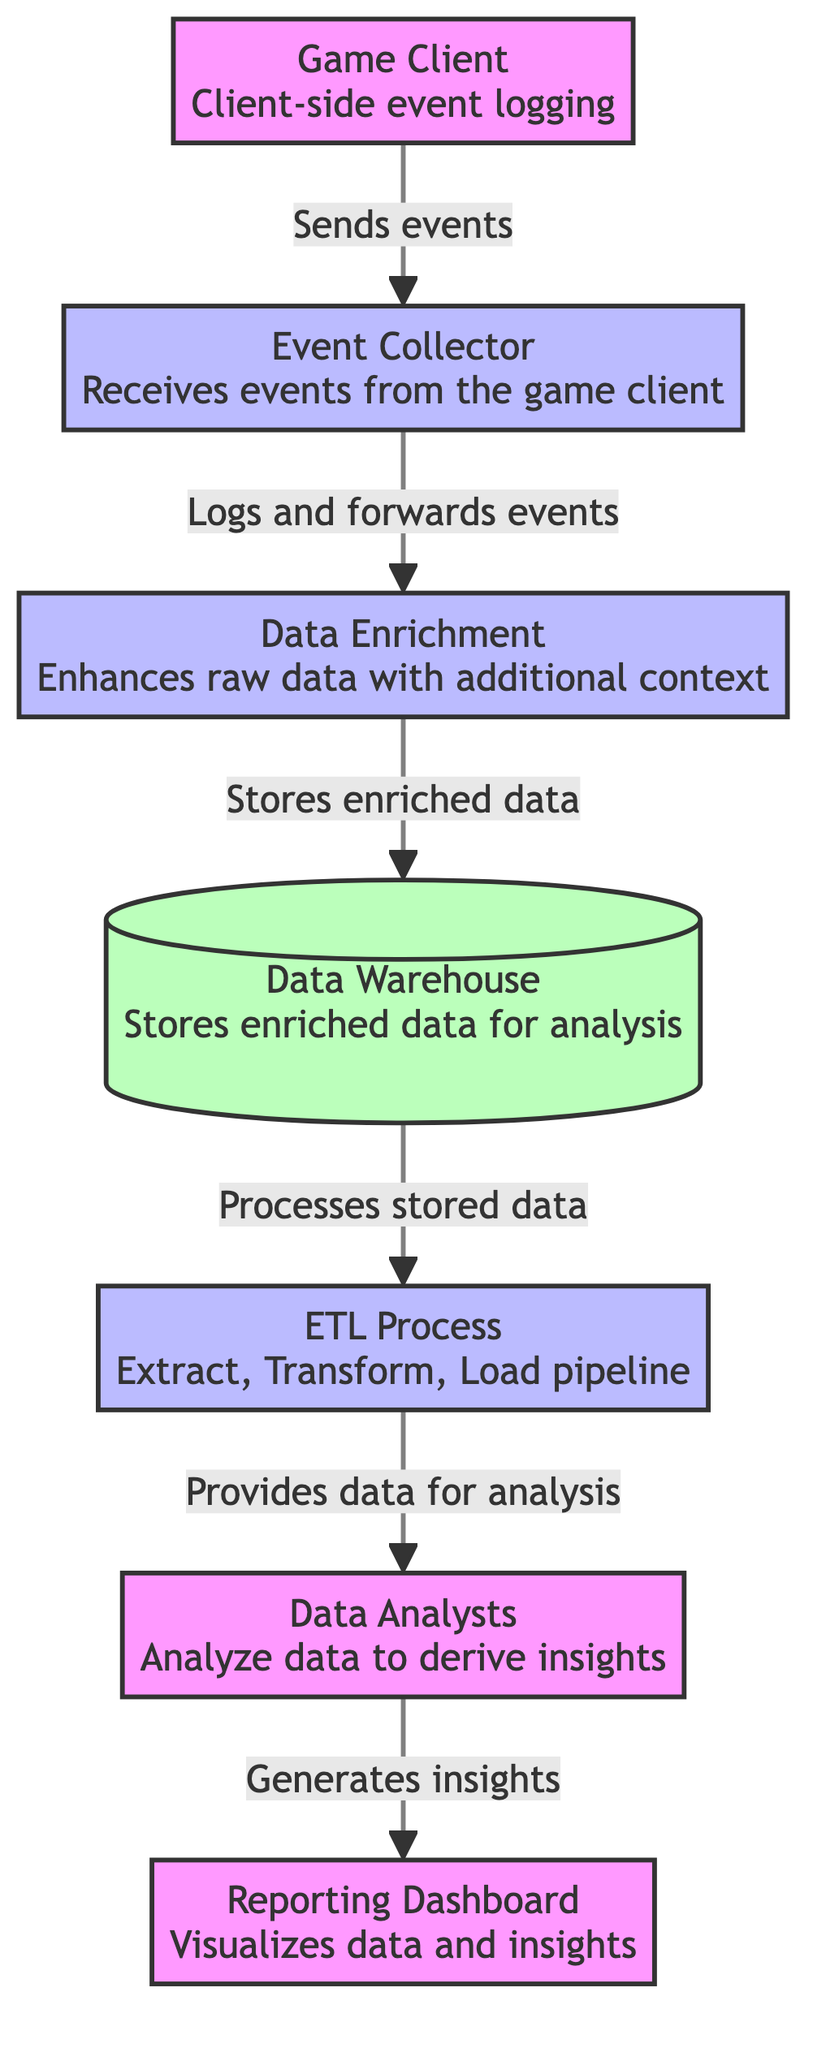What is the first step in the data flow? The diagram starts with the "Game Client" step, which involves client-side event logging. This is the first node in the flow and initiates the data collection process.
Answer: Game Client How many processes are shown in the diagram? There are four processes indicated in the diagram: "Event Collector," "Data Enrichment," "ETL Process," and "Data Analysts." Counting these nodes provides the total number of processes.
Answer: Four What type of data storage is used in the flow? The diagram indicates a "Data Warehouse" as the storage component for enriched data. The label clearly identifies this element as a storage unit for analysis.
Answer: Data Warehouse Which node receives events from the game client? The "Event Collector" node is the one that receives events directly from the game client according to the flow indicated in the diagram.
Answer: Event Collector What is the purpose of the ETL Process? The ETL Process is responsible for extracting, transforming, and loading data, facilitating the flow of processed data to the data analysts who derive insights from it. This function is specifically labeled in the diagram.
Answer: Extract, Transform, Load What node follows "Data Enrichment"? The node that follows "Data Enrichment" is the "Data Warehouse." This is determined by tracing the arrows from the "Data Enrichment" process to the next node in the flow.
Answer: Data Warehouse How does the data flow from event logging to reporting? The data begins at the "Game Client," flows to the "Event Collector," is enriched, stored in the "Data Warehouse," goes through the "ETL Process," analyzed by "Data Analysts," and ultimately visualized in the "Reporting Dashboard." This sequence illustrates the complete flow from data collection to report generation.
Answer: Through six nodes What is the final output node in the process? The final output node in the process is the "Reporting Dashboard," which visualizes the insights generated from the analyzed data. This is clearly marked as the last node in the flow.
Answer: Reporting Dashboard Which process enhances raw data with additional context? The "Data Enrichment" process enhances the raw data by adding relevant context. This function is explicitly described in the diagram.
Answer: Data Enrichment How many nodes are there in total in this diagram? Counting all the nodes displayed in the diagram, there are a total of seven distinct elements including both processes and storage.
Answer: Seven 